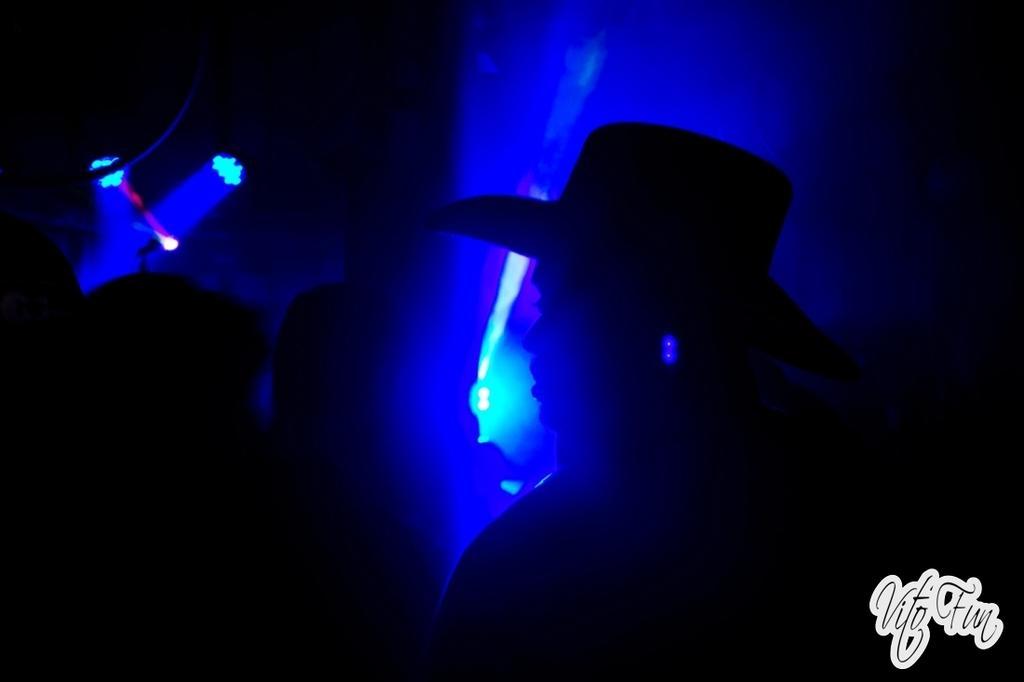Please provide a concise description of this image. In this image I can see group of people, background I can see few lights in blue color. 